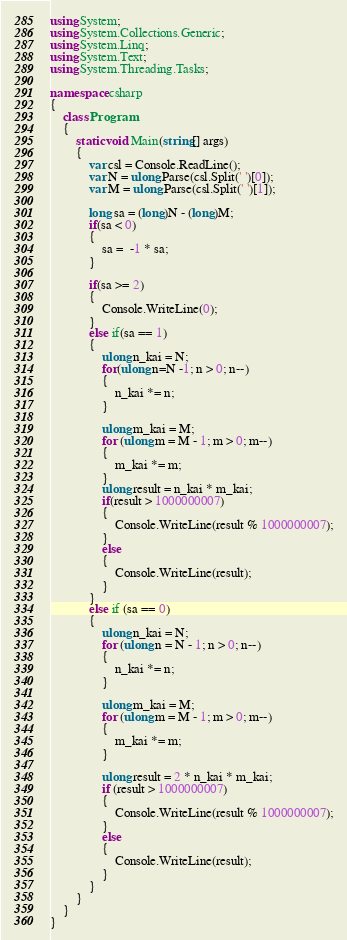<code> <loc_0><loc_0><loc_500><loc_500><_C#_>using System;
using System.Collections.Generic;
using System.Linq;
using System.Text;
using System.Threading.Tasks;

namespace csharp
{
    class Program
    {
        static void Main(string[] args)
        {
            var csl = Console.ReadLine();
            var N = ulong.Parse(csl.Split(' ')[0]);
            var M = ulong.Parse(csl.Split(' ')[1]);

            long sa = (long)N - (long)M;
            if(sa < 0)
            {
                sa =  -1 * sa;
            }

            if(sa >= 2)
            {
                Console.WriteLine(0);
            }
            else if(sa == 1)
            {
                ulong n_kai = N;
                for(ulong n=N -1; n > 0; n--)
                {
                    n_kai *= n;
                }

                ulong m_kai = M;
                for (ulong m = M - 1; m > 0; m--)
                {
                    m_kai *= m;
                }
                ulong result = n_kai * m_kai;
                if(result > 1000000007)
                {
                    Console.WriteLine(result % 1000000007);
                }
                else
                {
                    Console.WriteLine(result);
                }
            }
            else if (sa == 0)
            {
                ulong n_kai = N;
                for (ulong n = N - 1; n > 0; n--)
                {
                    n_kai *= n;
                }

                ulong m_kai = M;
                for (ulong m = M - 1; m > 0; m--)
                {
                    m_kai *= m;
                }

                ulong result = 2 * n_kai * m_kai;
                if (result > 1000000007)
                {
                    Console.WriteLine(result % 1000000007);
                }
                else
                {
                    Console.WriteLine(result);
                }
            }
        }
    }
}
</code> 